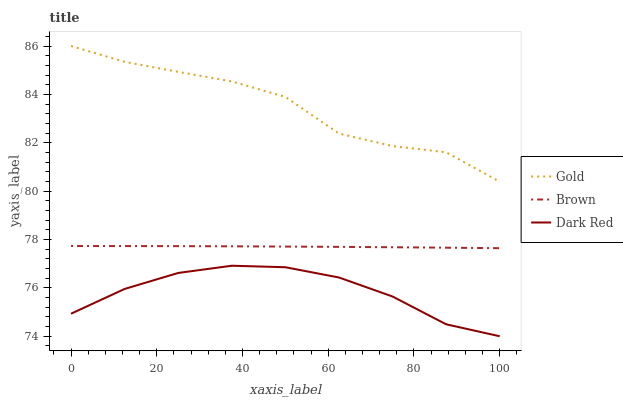Does Dark Red have the minimum area under the curve?
Answer yes or no. Yes. Does Gold have the maximum area under the curve?
Answer yes or no. Yes. Does Gold have the minimum area under the curve?
Answer yes or no. No. Does Dark Red have the maximum area under the curve?
Answer yes or no. No. Is Brown the smoothest?
Answer yes or no. Yes. Is Gold the roughest?
Answer yes or no. Yes. Is Dark Red the smoothest?
Answer yes or no. No. Is Dark Red the roughest?
Answer yes or no. No. Does Dark Red have the lowest value?
Answer yes or no. Yes. Does Gold have the lowest value?
Answer yes or no. No. Does Gold have the highest value?
Answer yes or no. Yes. Does Dark Red have the highest value?
Answer yes or no. No. Is Dark Red less than Brown?
Answer yes or no. Yes. Is Brown greater than Dark Red?
Answer yes or no. Yes. Does Dark Red intersect Brown?
Answer yes or no. No. 